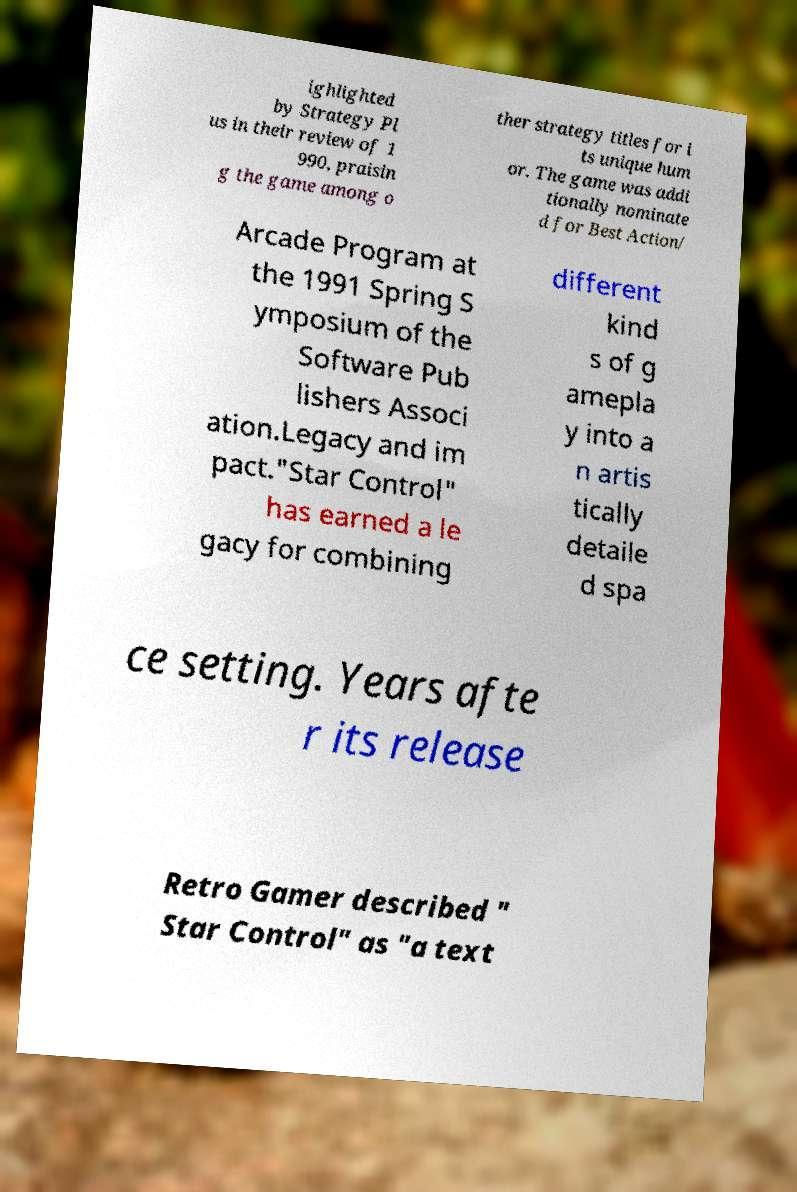Can you accurately transcribe the text from the provided image for me? ighlighted by Strategy Pl us in their review of 1 990, praisin g the game among o ther strategy titles for i ts unique hum or. The game was addi tionally nominate d for Best Action/ Arcade Program at the 1991 Spring S ymposium of the Software Pub lishers Associ ation.Legacy and im pact."Star Control" has earned a le gacy for combining different kind s of g amepla y into a n artis tically detaile d spa ce setting. Years afte r its release Retro Gamer described " Star Control" as "a text 